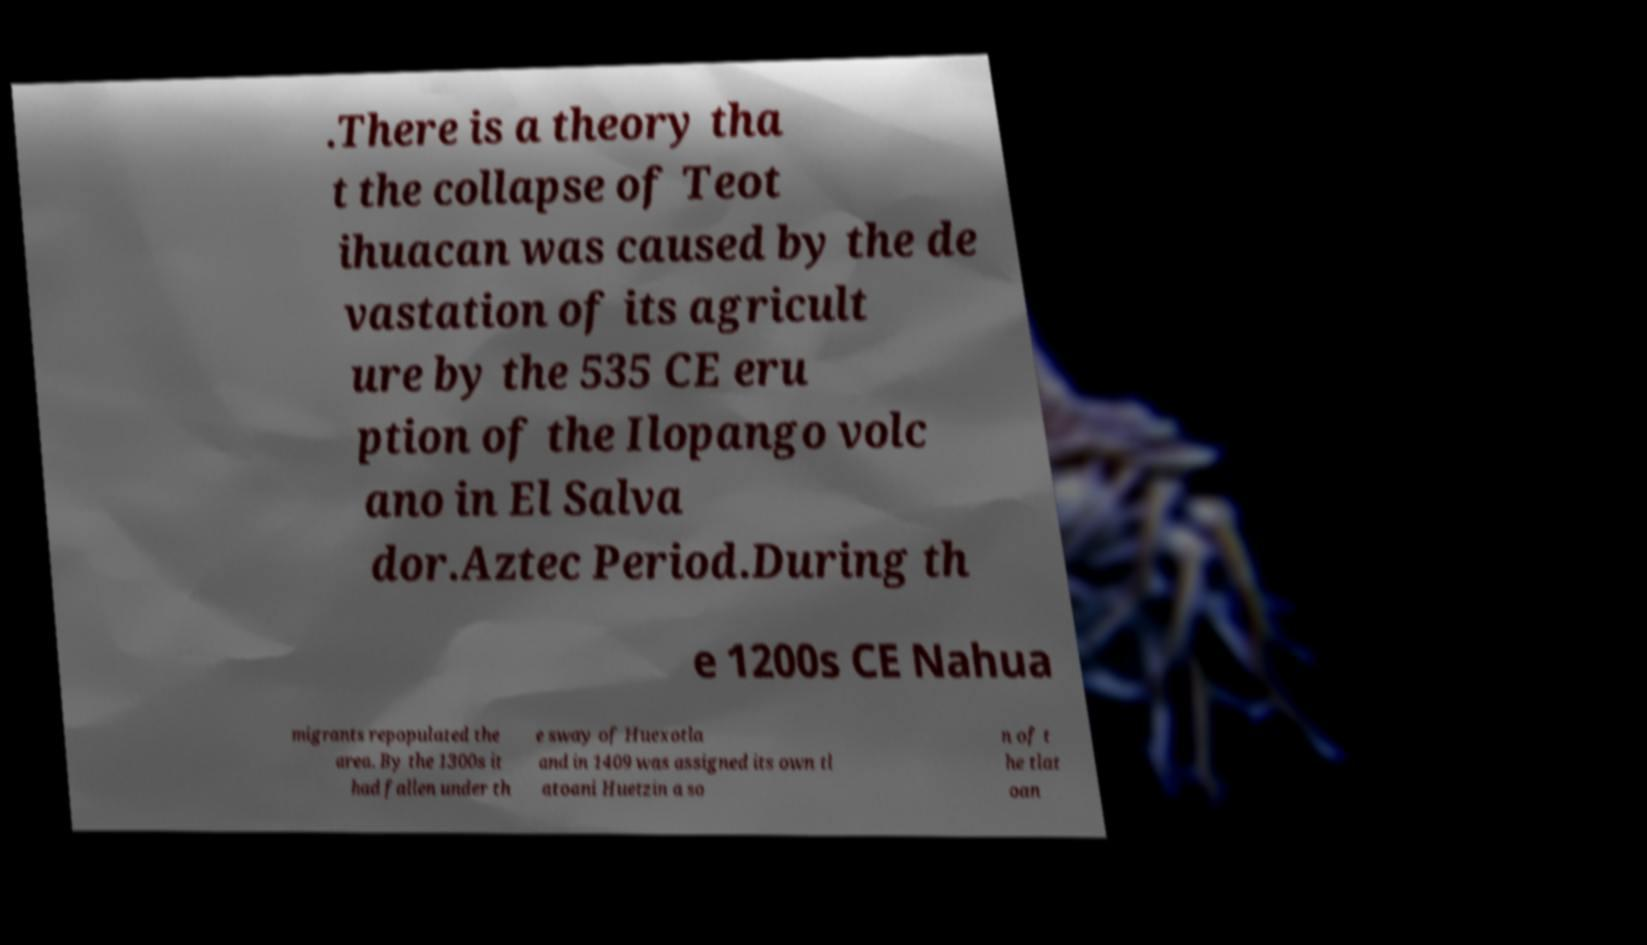There's text embedded in this image that I need extracted. Can you transcribe it verbatim? .There is a theory tha t the collapse of Teot ihuacan was caused by the de vastation of its agricult ure by the 535 CE eru ption of the Ilopango volc ano in El Salva dor.Aztec Period.During th e 1200s CE Nahua migrants repopulated the area. By the 1300s it had fallen under th e sway of Huexotla and in 1409 was assigned its own tl atoani Huetzin a so n of t he tlat oan 